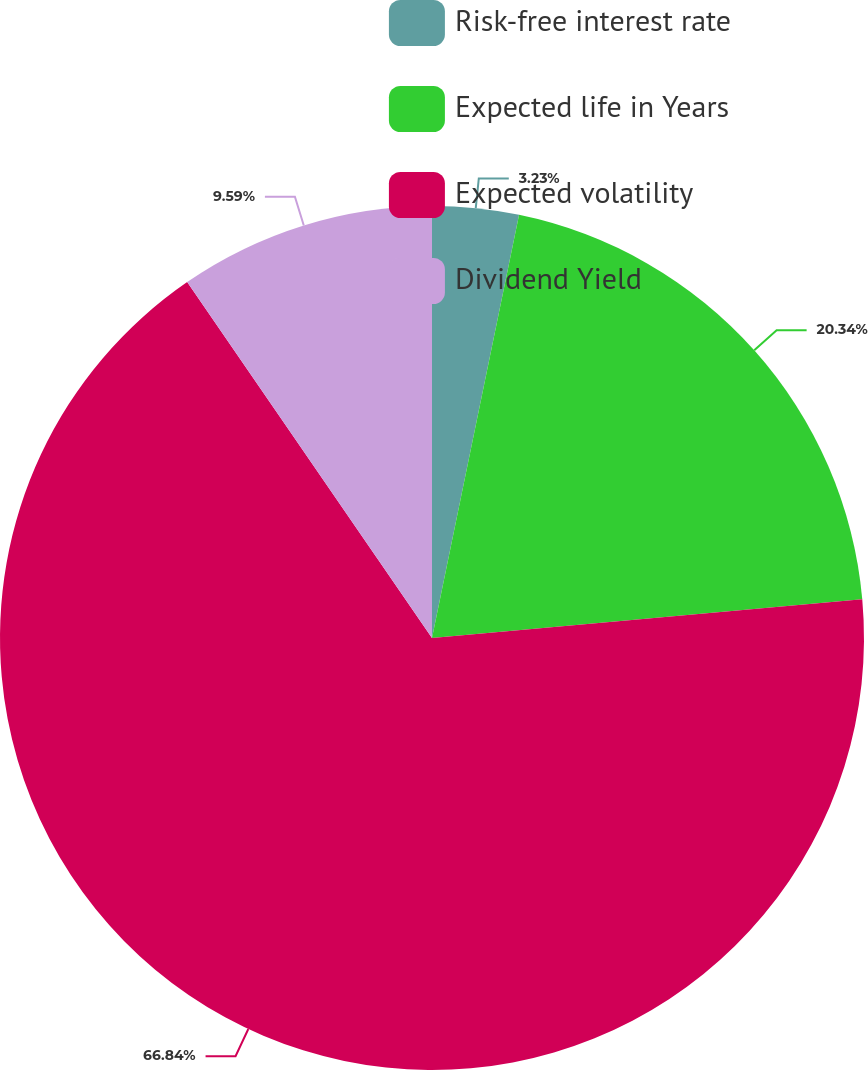Convert chart. <chart><loc_0><loc_0><loc_500><loc_500><pie_chart><fcel>Risk-free interest rate<fcel>Expected life in Years<fcel>Expected volatility<fcel>Dividend Yield<nl><fcel>3.23%<fcel>20.34%<fcel>66.84%<fcel>9.59%<nl></chart> 